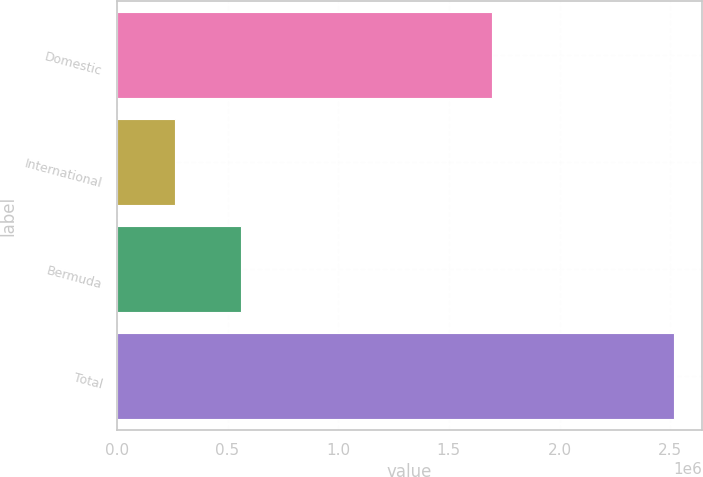Convert chart. <chart><loc_0><loc_0><loc_500><loc_500><bar_chart><fcel>Domestic<fcel>International<fcel>Bermuda<fcel>Total<nl><fcel>1.69521e+06<fcel>261611<fcel>560793<fcel>2.51761e+06<nl></chart> 